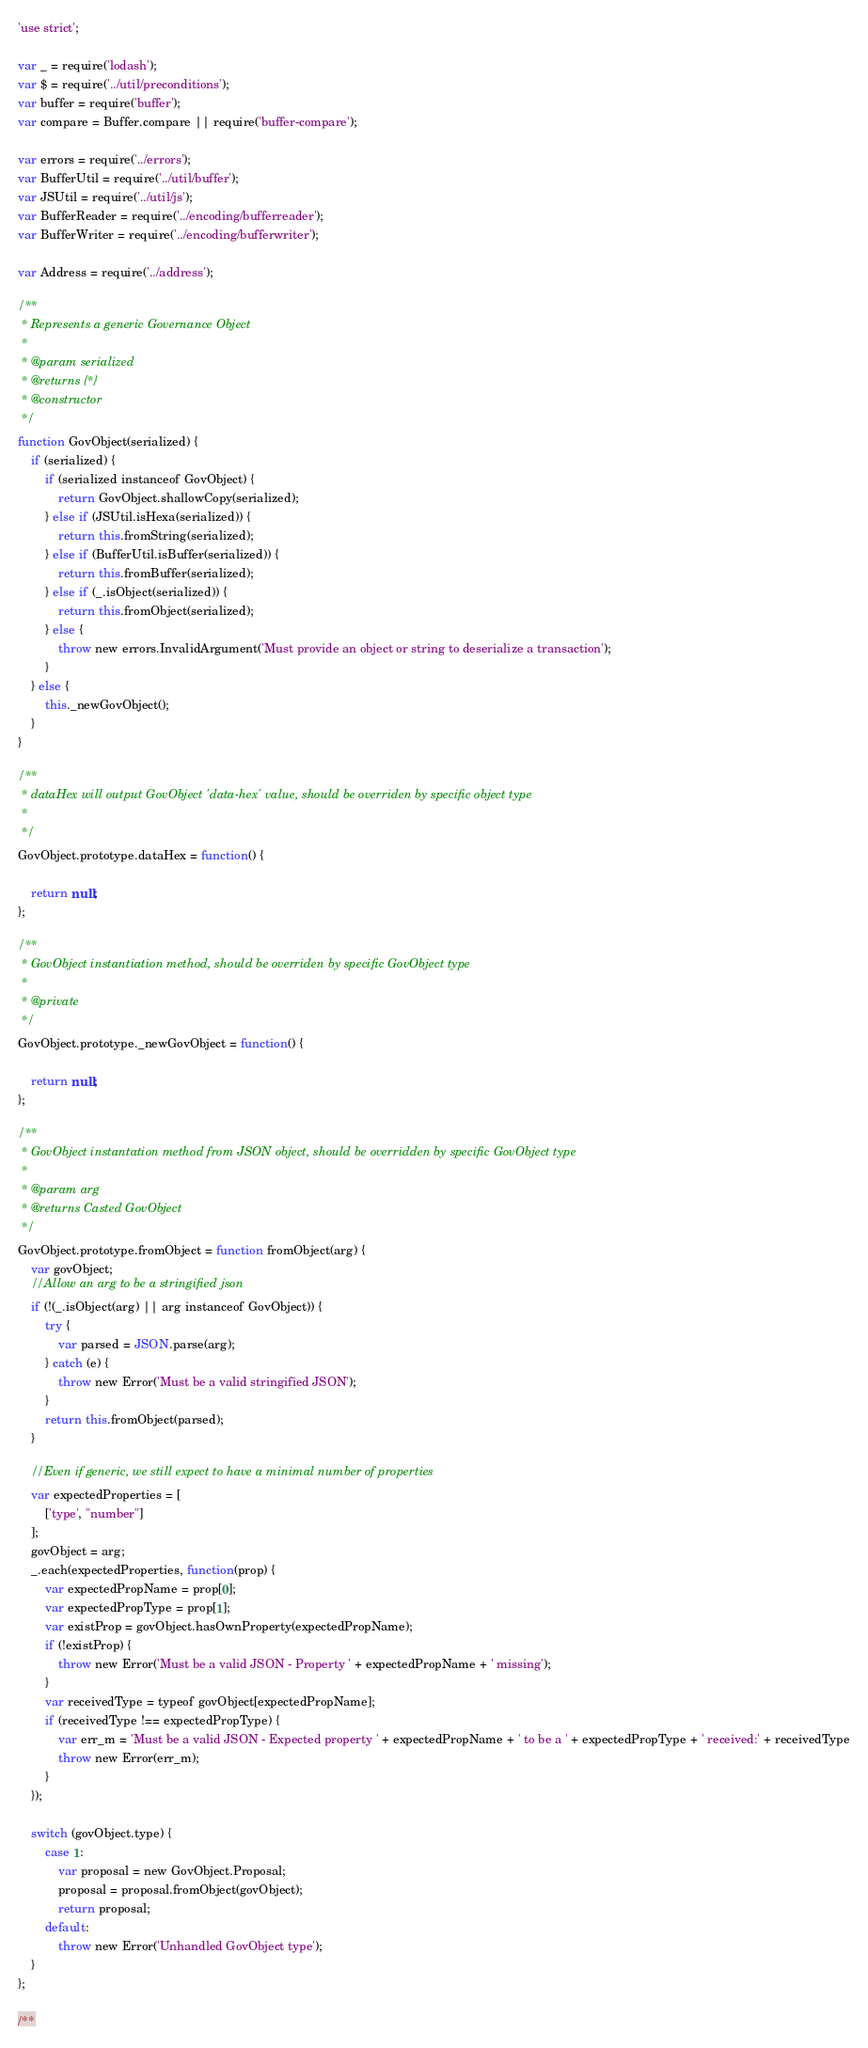<code> <loc_0><loc_0><loc_500><loc_500><_JavaScript_>'use strict';

var _ = require('lodash');
var $ = require('../util/preconditions');
var buffer = require('buffer');
var compare = Buffer.compare || require('buffer-compare');

var errors = require('../errors');
var BufferUtil = require('../util/buffer');
var JSUtil = require('../util/js');
var BufferReader = require('../encoding/bufferreader');
var BufferWriter = require('../encoding/bufferwriter');

var Address = require('../address');

/**
 * Represents a generic Governance Object
 *
 * @param serialized
 * @returns {*}
 * @constructor
 */
function GovObject(serialized) {
    if (serialized) {
        if (serialized instanceof GovObject) {
            return GovObject.shallowCopy(serialized);
        } else if (JSUtil.isHexa(serialized)) {
            return this.fromString(serialized);
        } else if (BufferUtil.isBuffer(serialized)) {
            return this.fromBuffer(serialized);
        } else if (_.isObject(serialized)) {
            return this.fromObject(serialized);
        } else {
            throw new errors.InvalidArgument('Must provide an object or string to deserialize a transaction');
        }
    } else {
        this._newGovObject();
    }
}

/**
 * dataHex will output GovObject 'data-hex' value, should be overriden by specific object type
 *
 */
GovObject.prototype.dataHex = function() {

    return null;
};

/**
 * GovObject instantiation method, should be overriden by specific GovObject type
 *
 * @private
 */
GovObject.prototype._newGovObject = function() {

    return null;
};

/**
 * GovObject instantation method from JSON object, should be overridden by specific GovObject type
 *
 * @param arg
 * @returns Casted GovObject
 */
GovObject.prototype.fromObject = function fromObject(arg) {
    var govObject;
    //Allow an arg to be a stringified json
    if (!(_.isObject(arg) || arg instanceof GovObject)) {
        try {
            var parsed = JSON.parse(arg);
        } catch (e) {
            throw new Error('Must be a valid stringified JSON');
        }
        return this.fromObject(parsed);
    }

    //Even if generic, we still expect to have a minimal number of properties
    var expectedProperties = [
        ['type', "number"]
    ];
    govObject = arg;
    _.each(expectedProperties, function(prop) {
        var expectedPropName = prop[0];
        var expectedPropType = prop[1];
        var existProp = govObject.hasOwnProperty(expectedPropName);
        if (!existProp) {
            throw new Error('Must be a valid JSON - Property ' + expectedPropName + ' missing');
        }
        var receivedType = typeof govObject[expectedPropName];
        if (receivedType !== expectedPropType) {
            var err_m = 'Must be a valid JSON - Expected property ' + expectedPropName + ' to be a ' + expectedPropType + ' received:' + receivedType
            throw new Error(err_m);
        }
    });

    switch (govObject.type) {
        case 1:
            var proposal = new GovObject.Proposal;
            proposal = proposal.fromObject(govObject);
            return proposal;
        default:
            throw new Error('Unhandled GovObject type');
    }
};

/**</code> 